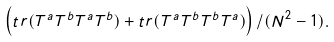<formula> <loc_0><loc_0><loc_500><loc_500>\left ( { t r } ( T ^ { a } T ^ { b } T ^ { a } T ^ { b } ) + { t r } ( T ^ { a } T ^ { b } T ^ { b } T ^ { a } ) \right ) / ( N ^ { 2 } - 1 ) .</formula> 